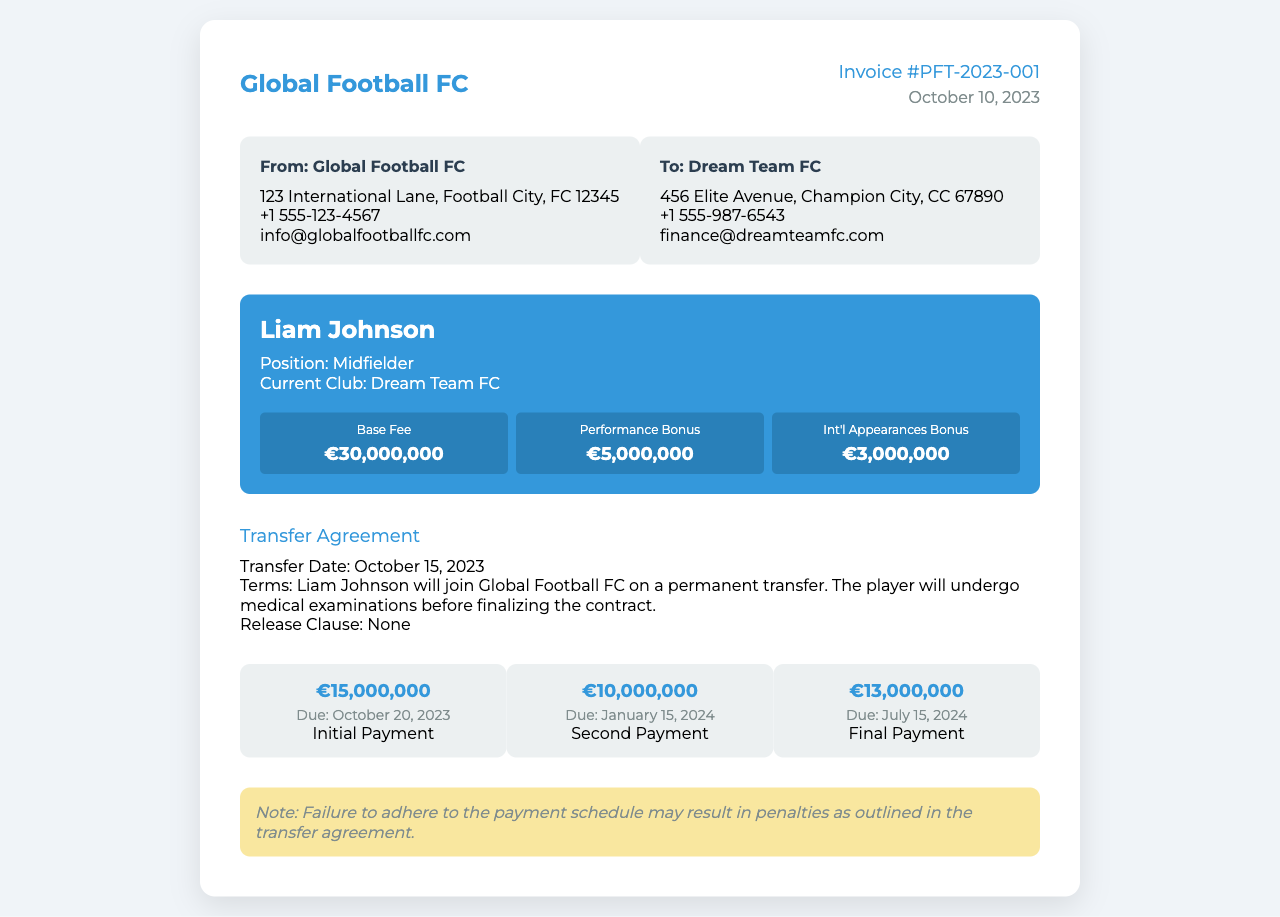What is the invoice number? The invoice number is listed at the top right corner of the document.
Answer: PFT-2023-001 What is the total fee for the player? The total fee is calculated by summing the base fee, performance bonus, and international appearances bonus.
Answer: €38,000,000 Who is the player being transferred? The player's name is prominently displayed in the player details section.
Answer: Liam Johnson What is the payment due date for the initial payment? The due date for the initial payment is specified in the payment schedule section.
Answer: October 20, 2023 What club is acquiring the player? The acquiring club is mentioned in the "To" section of the document.
Answer: Global Football FC What position does Liam Johnson play? The player's position is mentioned directly below the player's name in the details section.
Answer: Midfielder How many payments are outlined in the payment schedule? The payment schedule lists each payment separately.
Answer: Three What is the performance bonus amount? The performance bonus is one of the fee details listed.
Answer: €5,000,000 What is explicitly noted regarding the payment schedule consequences? The note at the bottom of the document refers to potential consequences of non-adherence to the schedule.
Answer: Penalties 